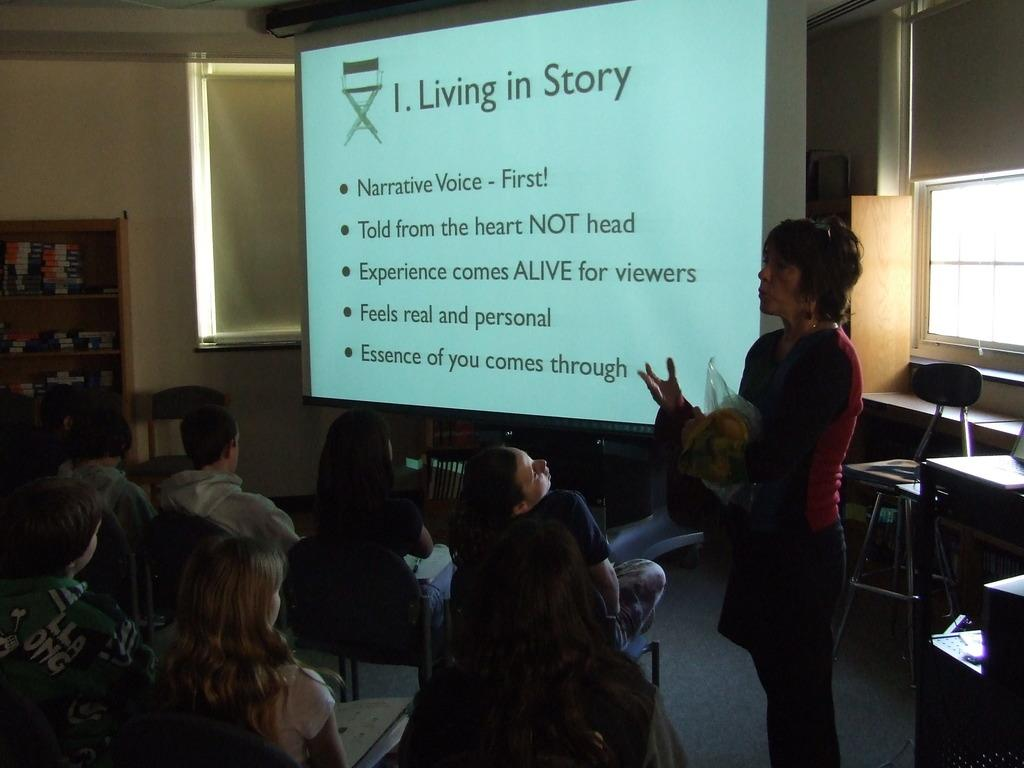What is the woman in the image wearing? The woman is wearing a red dress in the image. What is the woman doing in the image? The woman is standing and speaking in the image. Who is the woman standing in front of? The woman is standing in front of a group of people in the image. What is beside the woman in the image? There is a projected image beside the woman in the image. What type of map is the woman holding in the image? There is no map present in the image; the woman is standing in front of a group of people with a projected image beside her. 